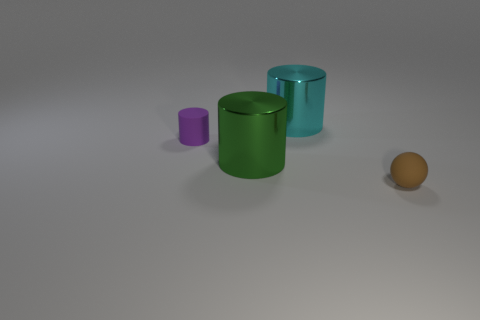What number of tiny brown objects are right of the purple rubber cylinder?
Make the answer very short. 1. Do the tiny object that is to the left of the rubber ball and the cylinder that is on the right side of the large green cylinder have the same material?
Ensure brevity in your answer.  No. How many objects are either large metal objects left of the cyan shiny thing or brown matte things?
Ensure brevity in your answer.  2. Is the number of large cyan metallic things to the right of the rubber cylinder less than the number of large green metallic things behind the green shiny object?
Your response must be concise. No. How many other objects are there of the same size as the purple matte object?
Keep it short and to the point. 1. Is the material of the tiny purple object the same as the small object in front of the large green metal thing?
Your answer should be compact. Yes. What number of objects are tiny brown rubber things right of the small purple rubber thing or matte objects in front of the large green shiny object?
Give a very brief answer. 1. What is the color of the tiny cylinder?
Your response must be concise. Purple. Are there fewer cyan shiny objects in front of the rubber ball than small brown rubber balls?
Offer a terse response. Yes. Are there any other things that are the same shape as the brown rubber thing?
Your answer should be very brief. No. 